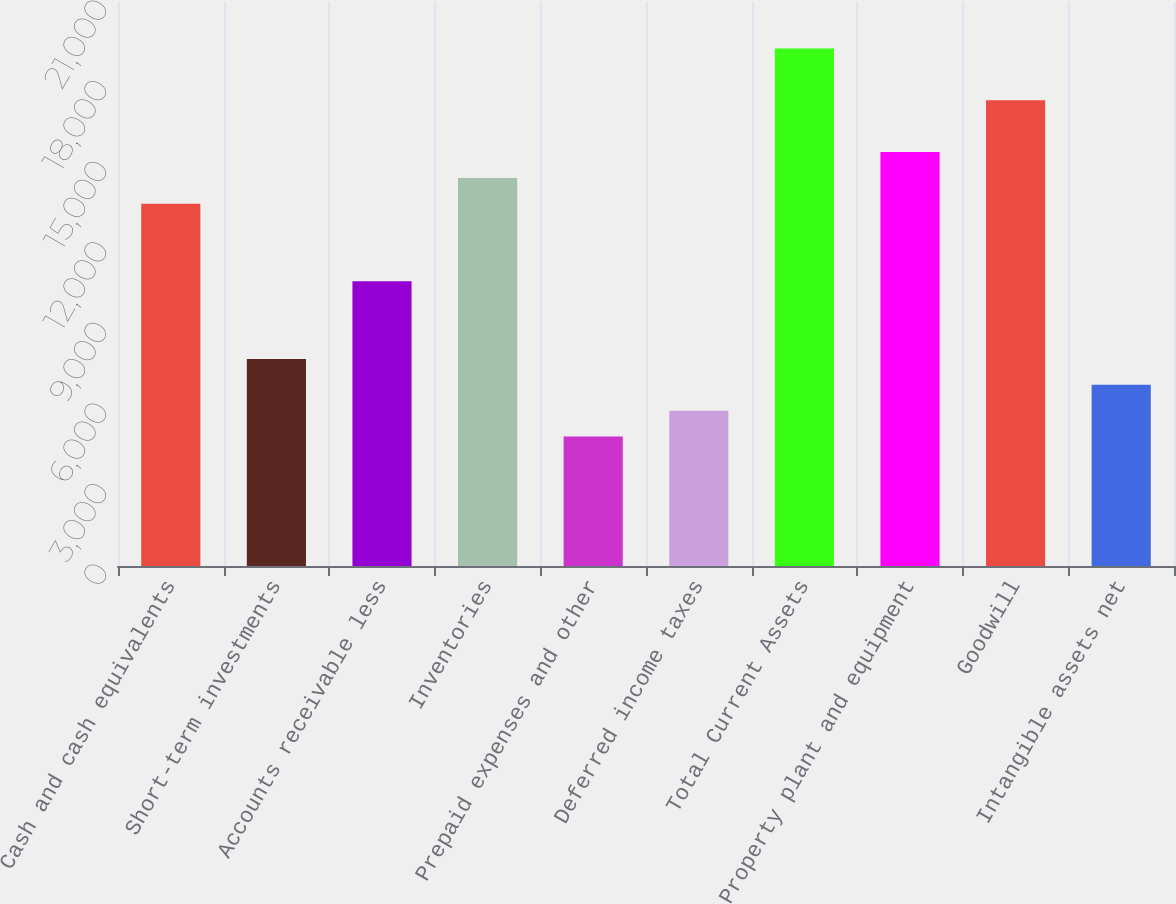<chart> <loc_0><loc_0><loc_500><loc_500><bar_chart><fcel>Cash and cash equivalents<fcel>Short-term investments<fcel>Accounts receivable less<fcel>Inventories<fcel>Prepaid expenses and other<fcel>Deferred income taxes<fcel>Total Current Assets<fcel>Property plant and equipment<fcel>Goodwill<fcel>Intangible assets net<nl><fcel>13487.9<fcel>7708.12<fcel>10598<fcel>14451.1<fcel>4818.25<fcel>5781.54<fcel>19267.6<fcel>15414.4<fcel>17341<fcel>6744.83<nl></chart> 